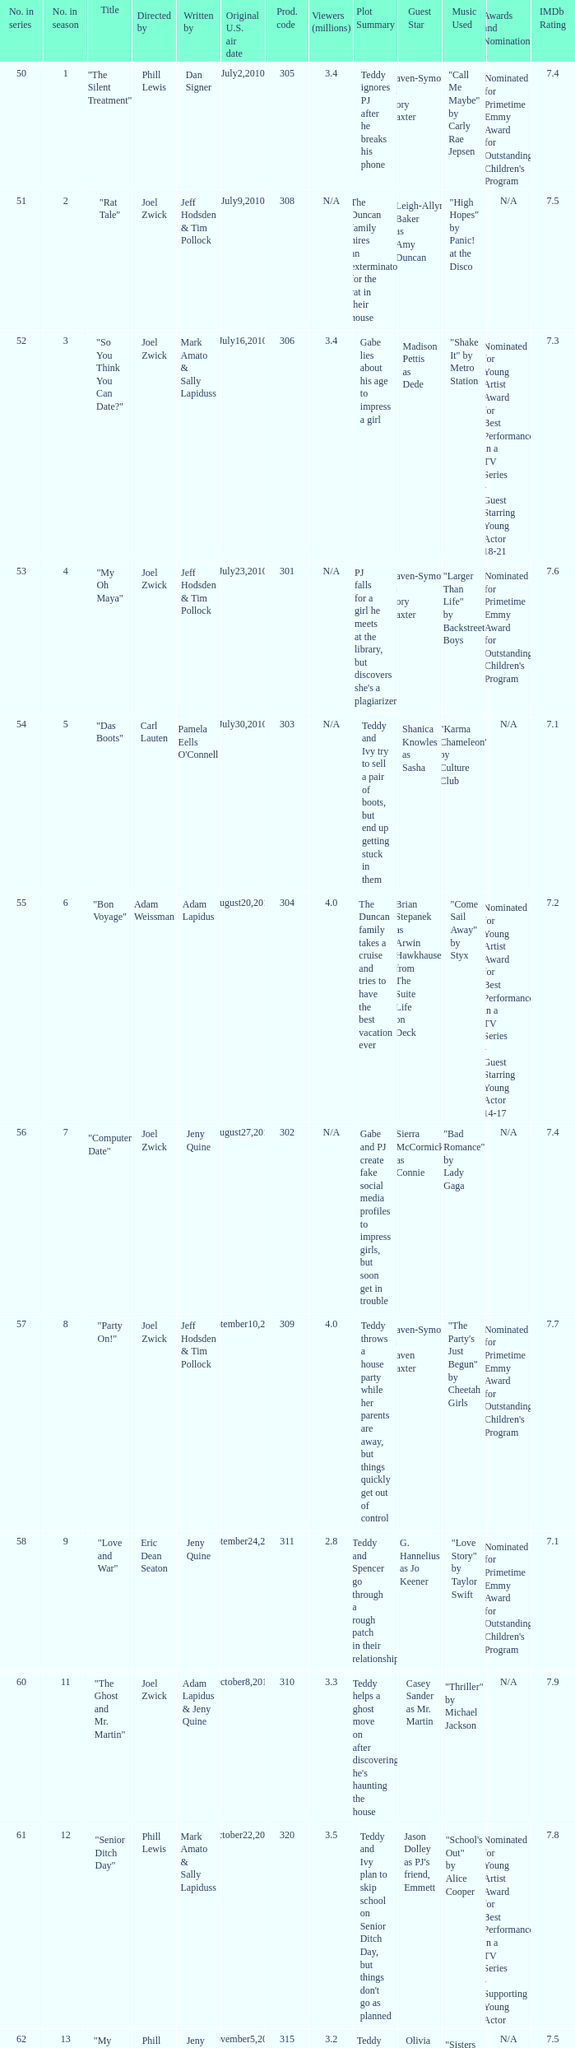For which us air date were there 4.4 million viewers? January14,2011. 